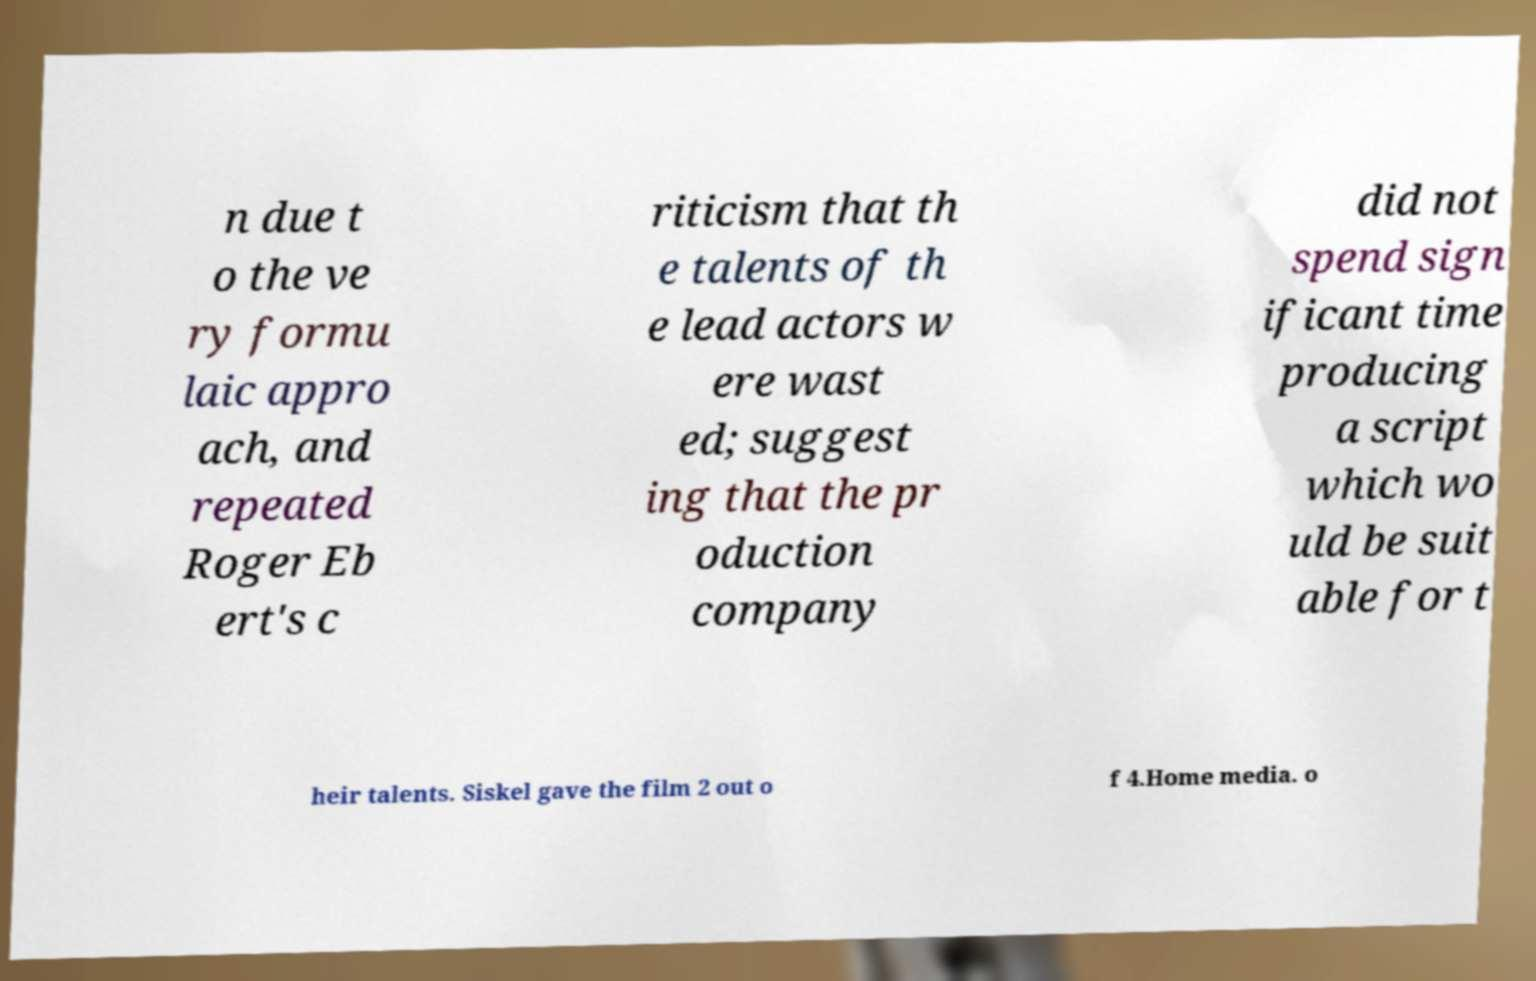Please read and relay the text visible in this image. What does it say? n due t o the ve ry formu laic appro ach, and repeated Roger Eb ert's c riticism that th e talents of th e lead actors w ere wast ed; suggest ing that the pr oduction company did not spend sign ificant time producing a script which wo uld be suit able for t heir talents. Siskel gave the film 2 out o f 4.Home media. o 